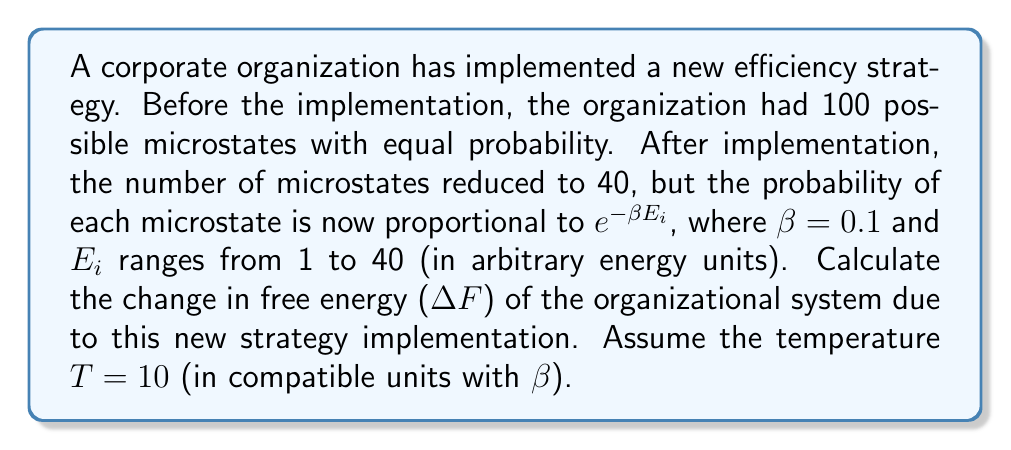Solve this math problem. To solve this problem, we'll use the formula for free energy in statistical mechanics:

$$ F = -kT \ln Z $$

Where F is free energy, k is Boltzmann's constant (which we'll treat as 1 for simplicity), T is temperature, and Z is the partition function.

Step 1: Calculate the free energy before implementation (F_before)
Before implementation, all 100 microstates had equal probability, so:

$$ Z_{before} = 100 $$
$$ F_{before} = -10 \ln(100) = -46.052 $$

Step 2: Calculate the partition function after implementation (Z_after)
After implementation, the probability of each microstate is proportional to $e^{-\beta E_i}$, so:

$$ Z_{after} = \sum_{i=1}^{40} e^{-0.1E_i} = \sum_{i=1}^{40} e^{-0.1i} $$

Using the formula for the sum of a geometric series:

$$ Z_{after} = \frac{e^{-0.1}(1-e^{-4})}{1-e^{-0.1}} = 9.1606 $$

Step 3: Calculate the free energy after implementation (F_after)

$$ F_{after} = -10 \ln(9.1606) = -22.150 $$

Step 4: Calculate the change in free energy (ΔF)

$$ \Delta F = F_{after} - F_{before} = -22.150 - (-46.052) = 23.902 $$
Answer: $\Delta F = 23.902$ 